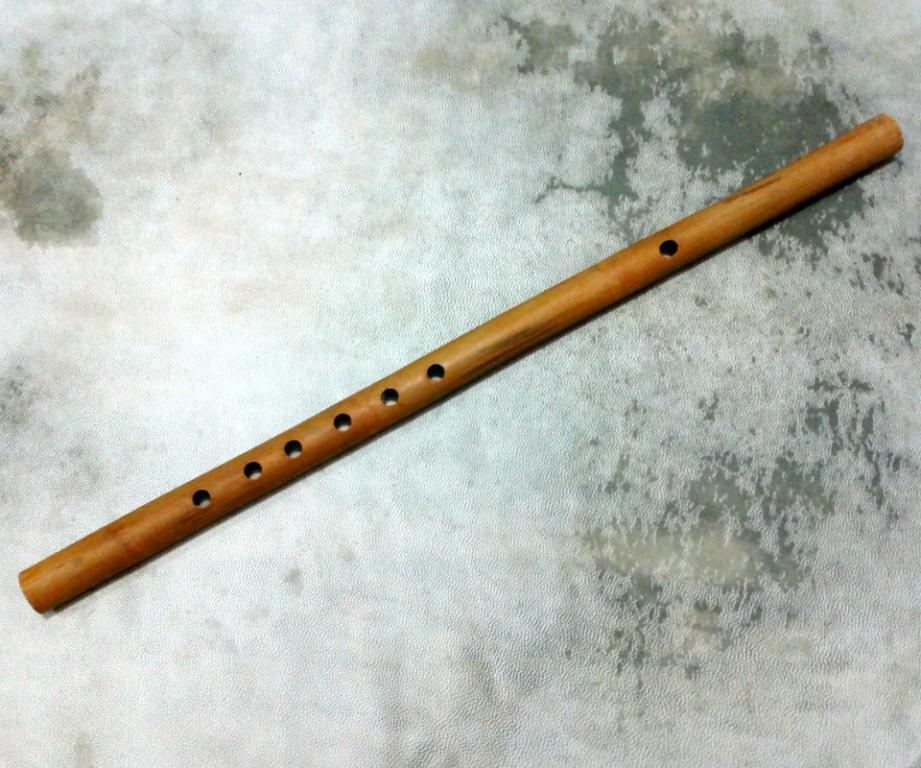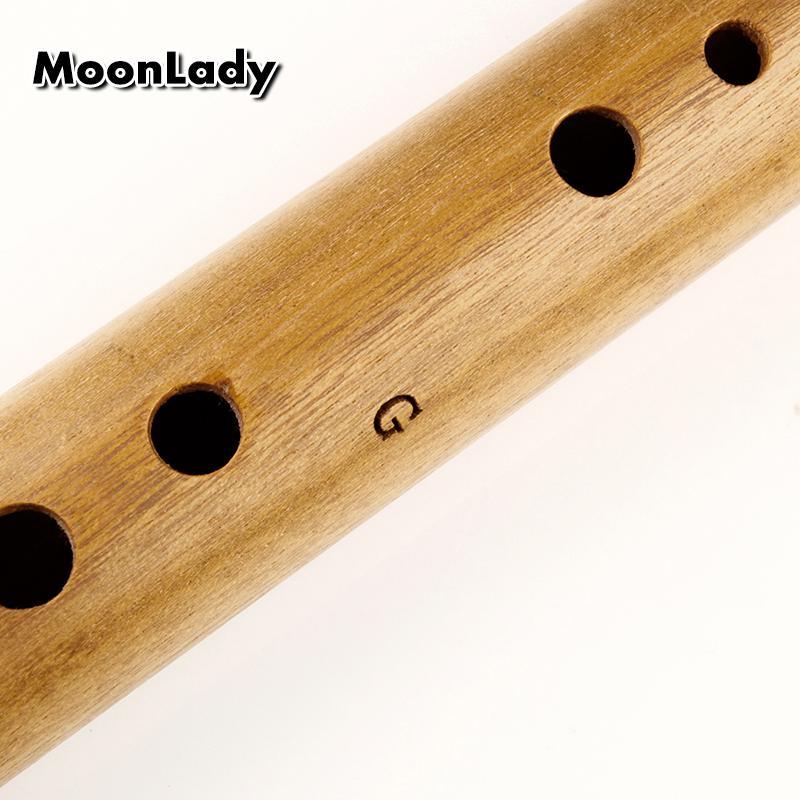The first image is the image on the left, the second image is the image on the right. Evaluate the accuracy of this statement regarding the images: "The left image contains a single wooden flute displayed diagonally with one end at the upper right, and the right image features multiple flutes displayed diagonally at the opposite angle.". Is it true? Answer yes or no. No. The first image is the image on the left, the second image is the image on the right. Analyze the images presented: Is the assertion "There is more than one wooden musical instrument in the right image and exactly one on the left." valid? Answer yes or no. No. 